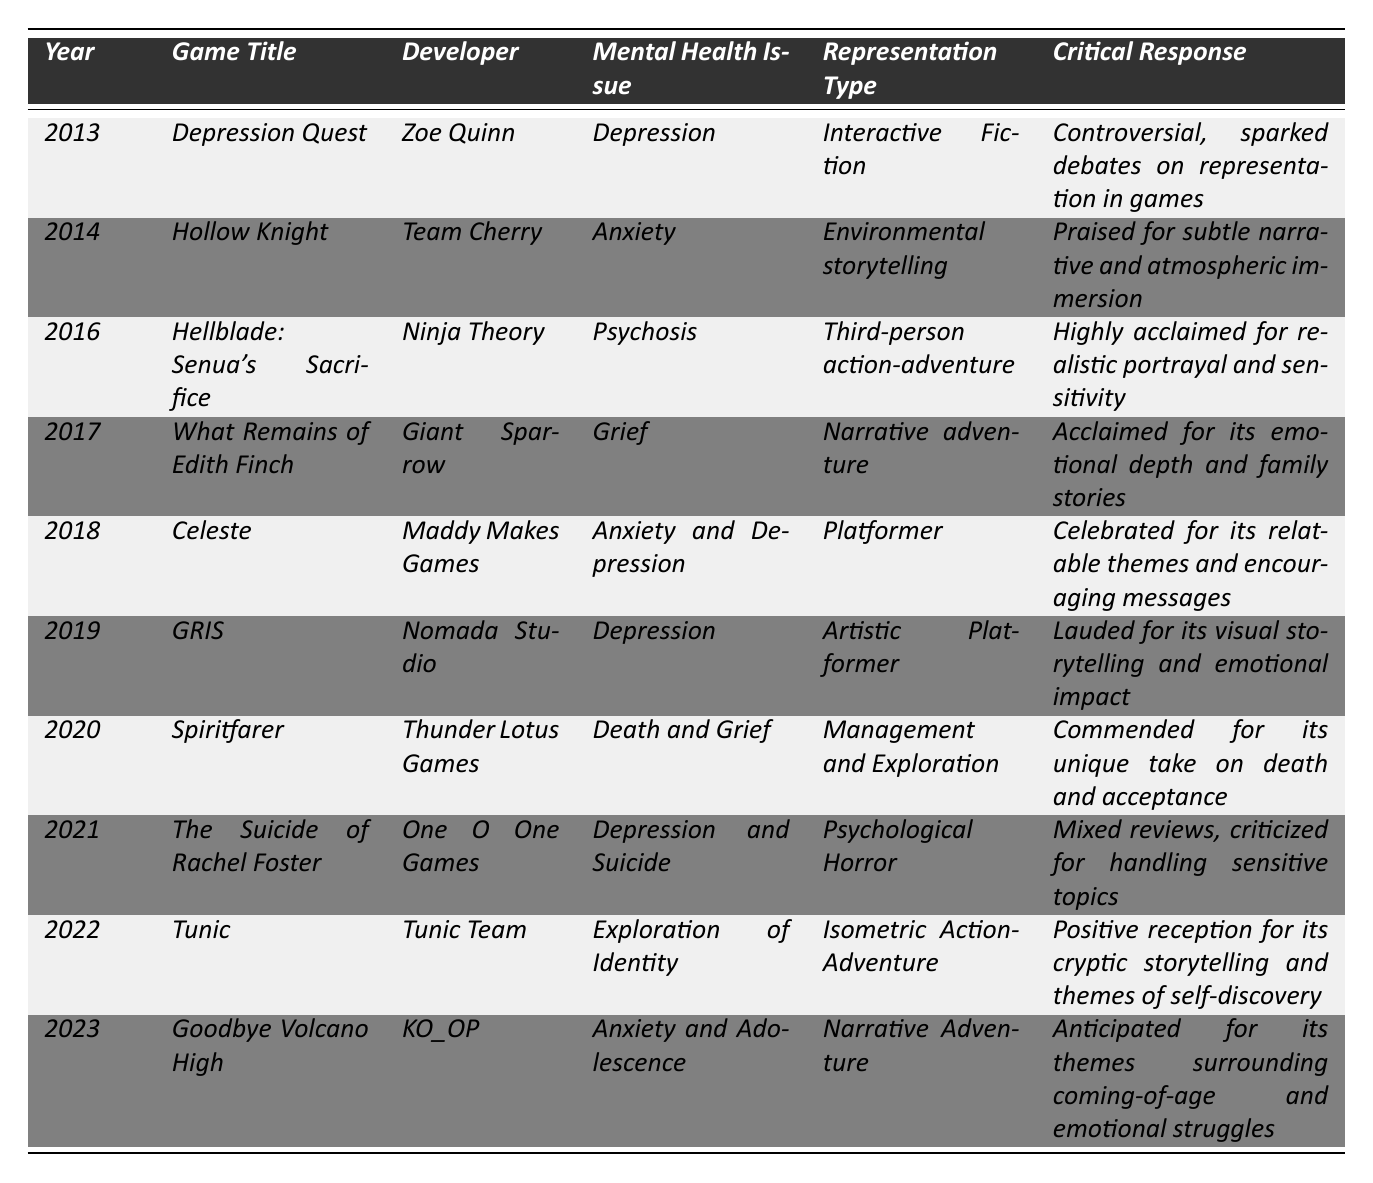What game focused on anxiety was released in 2014? Referring to the table, the game released in 2014 that addresses anxiety is "Hollow Knight."
Answer: Hollow Knight How many games from the list deal with depression as a mental health issue? In the table, the games dealing with depression are "Depression Quest," "GRIS," and "The Suicide of Rachel Foster." Thus, there are three games.
Answer: 3 What is the critical response for "Hellblade: Senua's Sacrifice"? The critical response for "Hellblade: Senua's Sacrifice" is "Highly acclaimed for realistic portrayal and sensitivity." This can be found directly in the table under the critical response column for that game.
Answer: Highly acclaimed for realistic portrayal and sensitivity Are there any games that address grief or loss? Yes, the table includes "What Remains of Edith Finch" and "Spiritfarer," both of which address grief or loss as their mental health issues.
Answer: Yes Which game received mixed reviews and was criticized for handling sensitive topics? The game with mixed reviews and criticism for its sensitive topic handling is "The Suicide of Rachel Foster." This can be found in the critical response section of the table.
Answer: The Suicide of Rachel Foster What type of representation does "Celeste" use for its themes of anxiety and depression? The representation type for "Celeste" is "Platformer," as listed in the table.
Answer: Platformer Which game has the emotional issue related to adolescence, and what year was it released? "Goodbye Volcano High" addresses anxiety and adolescence and was released in 2023 according to the table.
Answer: Goodbye Volcano High, 2023 How does the representation of mental health issues in indie games evolve from 2013 to 2023 in terms of critical response? The critical responses range from controversial to highly acclaimed, suggesting that the representation has evolved toward greater sensitivity and acclaim over the decade, with notable improvements in the treatment of these themes.
Answer: Improved sensitivity and acclaim over the decade In what year did a game about death and grief get released, and what is its title? "Spiritfarer" is the game released in 2020 that addresses death and grief, as shown in the table.
Answer: Spiritfarer, 2020 What year had two games addressing mental health issues related to depression? In 2013, "Depression Quest" and in 2019, "GRIS" both address depression, thus there are two years if including both games.
Answer: 2013 and 2019 